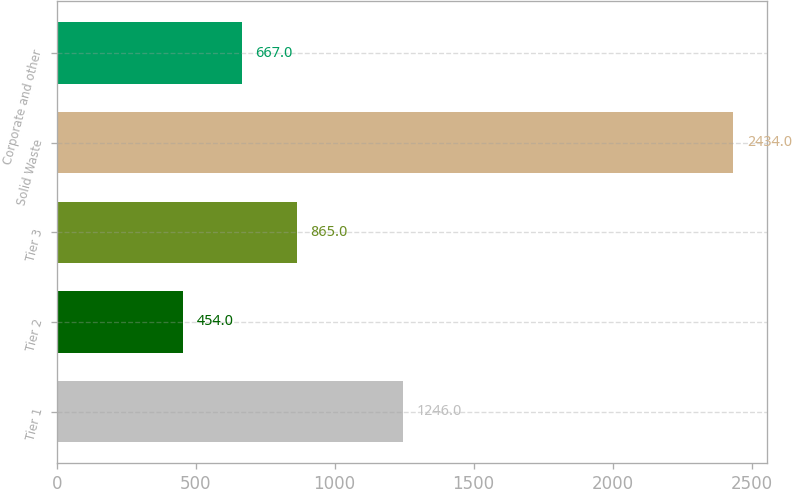Convert chart to OTSL. <chart><loc_0><loc_0><loc_500><loc_500><bar_chart><fcel>Tier 1<fcel>Tier 2<fcel>Tier 3<fcel>Solid Waste<fcel>Corporate and other<nl><fcel>1246<fcel>454<fcel>865<fcel>2434<fcel>667<nl></chart> 